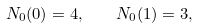Convert formula to latex. <formula><loc_0><loc_0><loc_500><loc_500>N _ { 0 } ( 0 ) = 4 , \quad N _ { 0 } ( 1 ) = 3 ,</formula> 